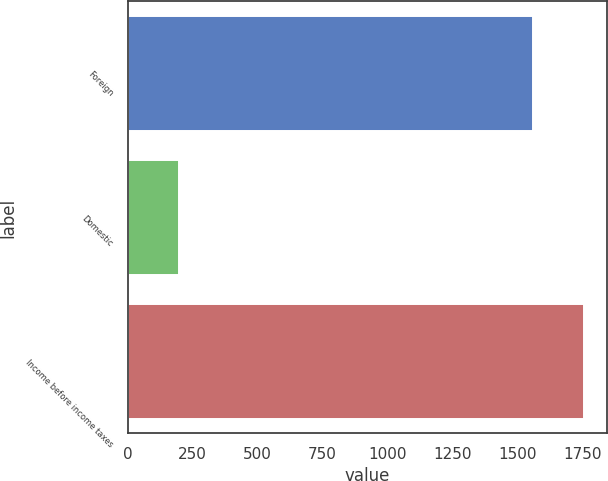Convert chart. <chart><loc_0><loc_0><loc_500><loc_500><bar_chart><fcel>Foreign<fcel>Domestic<fcel>Income before income taxes<nl><fcel>1559<fcel>198<fcel>1757<nl></chart> 